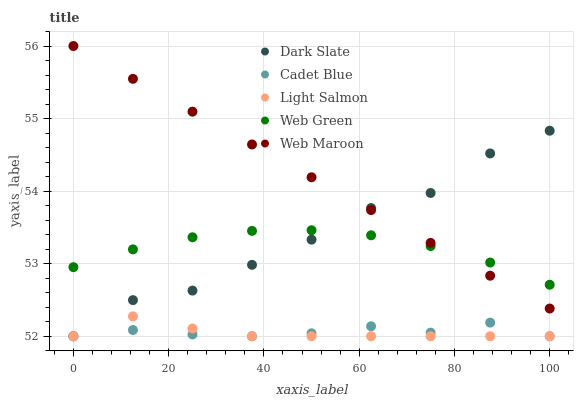Does Light Salmon have the minimum area under the curve?
Answer yes or no. Yes. Does Web Maroon have the maximum area under the curve?
Answer yes or no. Yes. Does Cadet Blue have the minimum area under the curve?
Answer yes or no. No. Does Cadet Blue have the maximum area under the curve?
Answer yes or no. No. Is Web Maroon the smoothest?
Answer yes or no. Yes. Is Dark Slate the roughest?
Answer yes or no. Yes. Is Light Salmon the smoothest?
Answer yes or no. No. Is Light Salmon the roughest?
Answer yes or no. No. Does Dark Slate have the lowest value?
Answer yes or no. Yes. Does Web Maroon have the lowest value?
Answer yes or no. No. Does Web Maroon have the highest value?
Answer yes or no. Yes. Does Light Salmon have the highest value?
Answer yes or no. No. Is Light Salmon less than Web Green?
Answer yes or no. Yes. Is Web Maroon greater than Cadet Blue?
Answer yes or no. Yes. Does Web Maroon intersect Dark Slate?
Answer yes or no. Yes. Is Web Maroon less than Dark Slate?
Answer yes or no. No. Is Web Maroon greater than Dark Slate?
Answer yes or no. No. Does Light Salmon intersect Web Green?
Answer yes or no. No. 